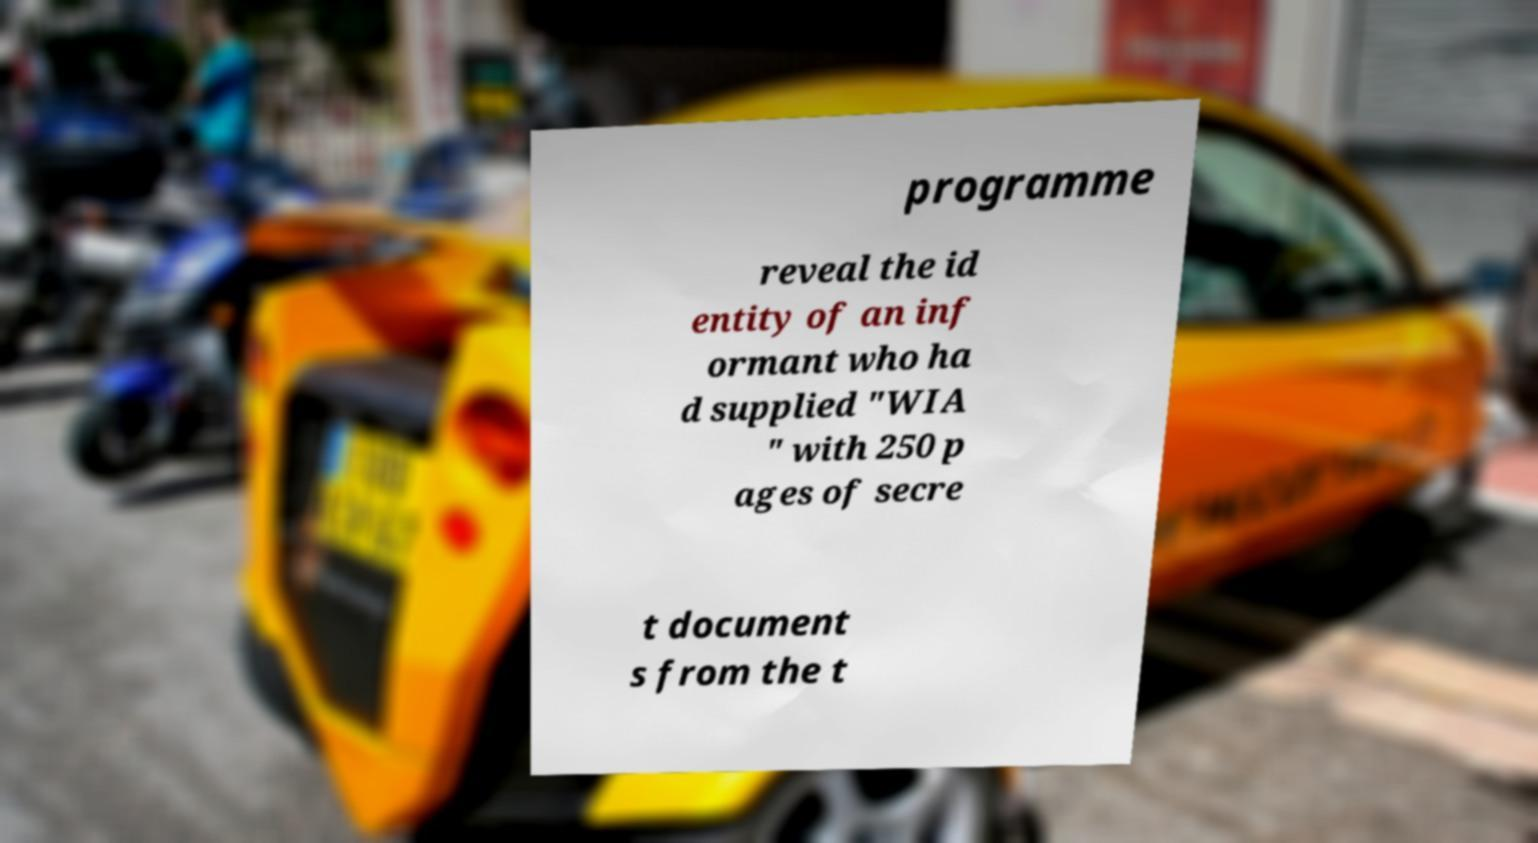Can you read and provide the text displayed in the image?This photo seems to have some interesting text. Can you extract and type it out for me? programme reveal the id entity of an inf ormant who ha d supplied "WIA " with 250 p ages of secre t document s from the t 